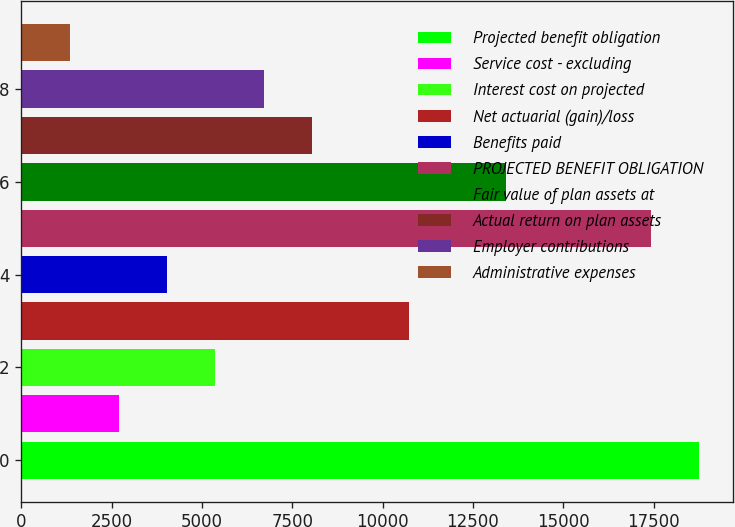<chart> <loc_0><loc_0><loc_500><loc_500><bar_chart><fcel>Projected benefit obligation<fcel>Service cost - excluding<fcel>Interest cost on projected<fcel>Net actuarial (gain)/loss<fcel>Benefits paid<fcel>PROJECTED BENEFIT OBLIGATION<fcel>Fair value of plan assets at<fcel>Actual return on plan assets<fcel>Employer contributions<fcel>Administrative expenses<nl><fcel>18761.6<fcel>2694.8<fcel>5372.6<fcel>10728.2<fcel>4033.7<fcel>17422.7<fcel>13406<fcel>8050.4<fcel>6711.5<fcel>1355.9<nl></chart> 